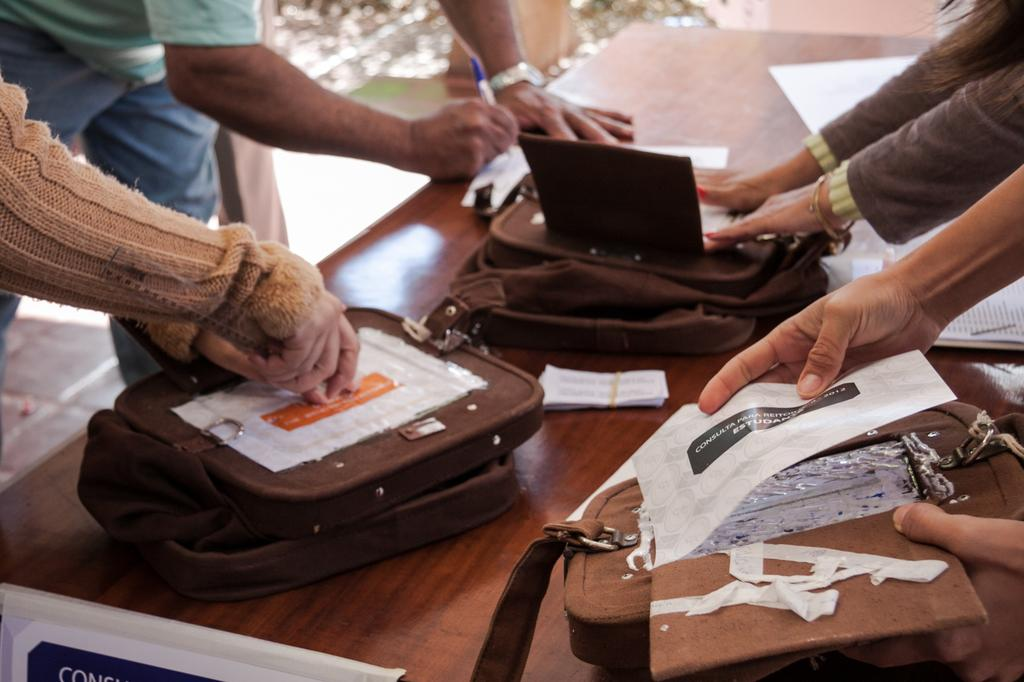What objects are present on the table in the image? There are many human hands, brown bags, and papers on the table. What is the color of the table? The table is in brown color. How many people are present in the image? The image only shows human hands, not whole people, so it is not possible to determine the number of people. What is the effect of the image on the temperature of the room? The image does not have any effect on the temperature of the room; it is a still image. 